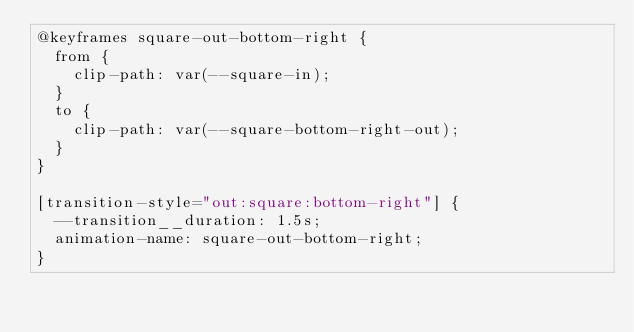Convert code to text. <code><loc_0><loc_0><loc_500><loc_500><_CSS_>@keyframes square-out-bottom-right {
  from {
    clip-path: var(--square-in);
  }
  to {
    clip-path: var(--square-bottom-right-out);
  }
}

[transition-style="out:square:bottom-right"] {
  --transition__duration: 1.5s;
  animation-name: square-out-bottom-right;
}</code> 